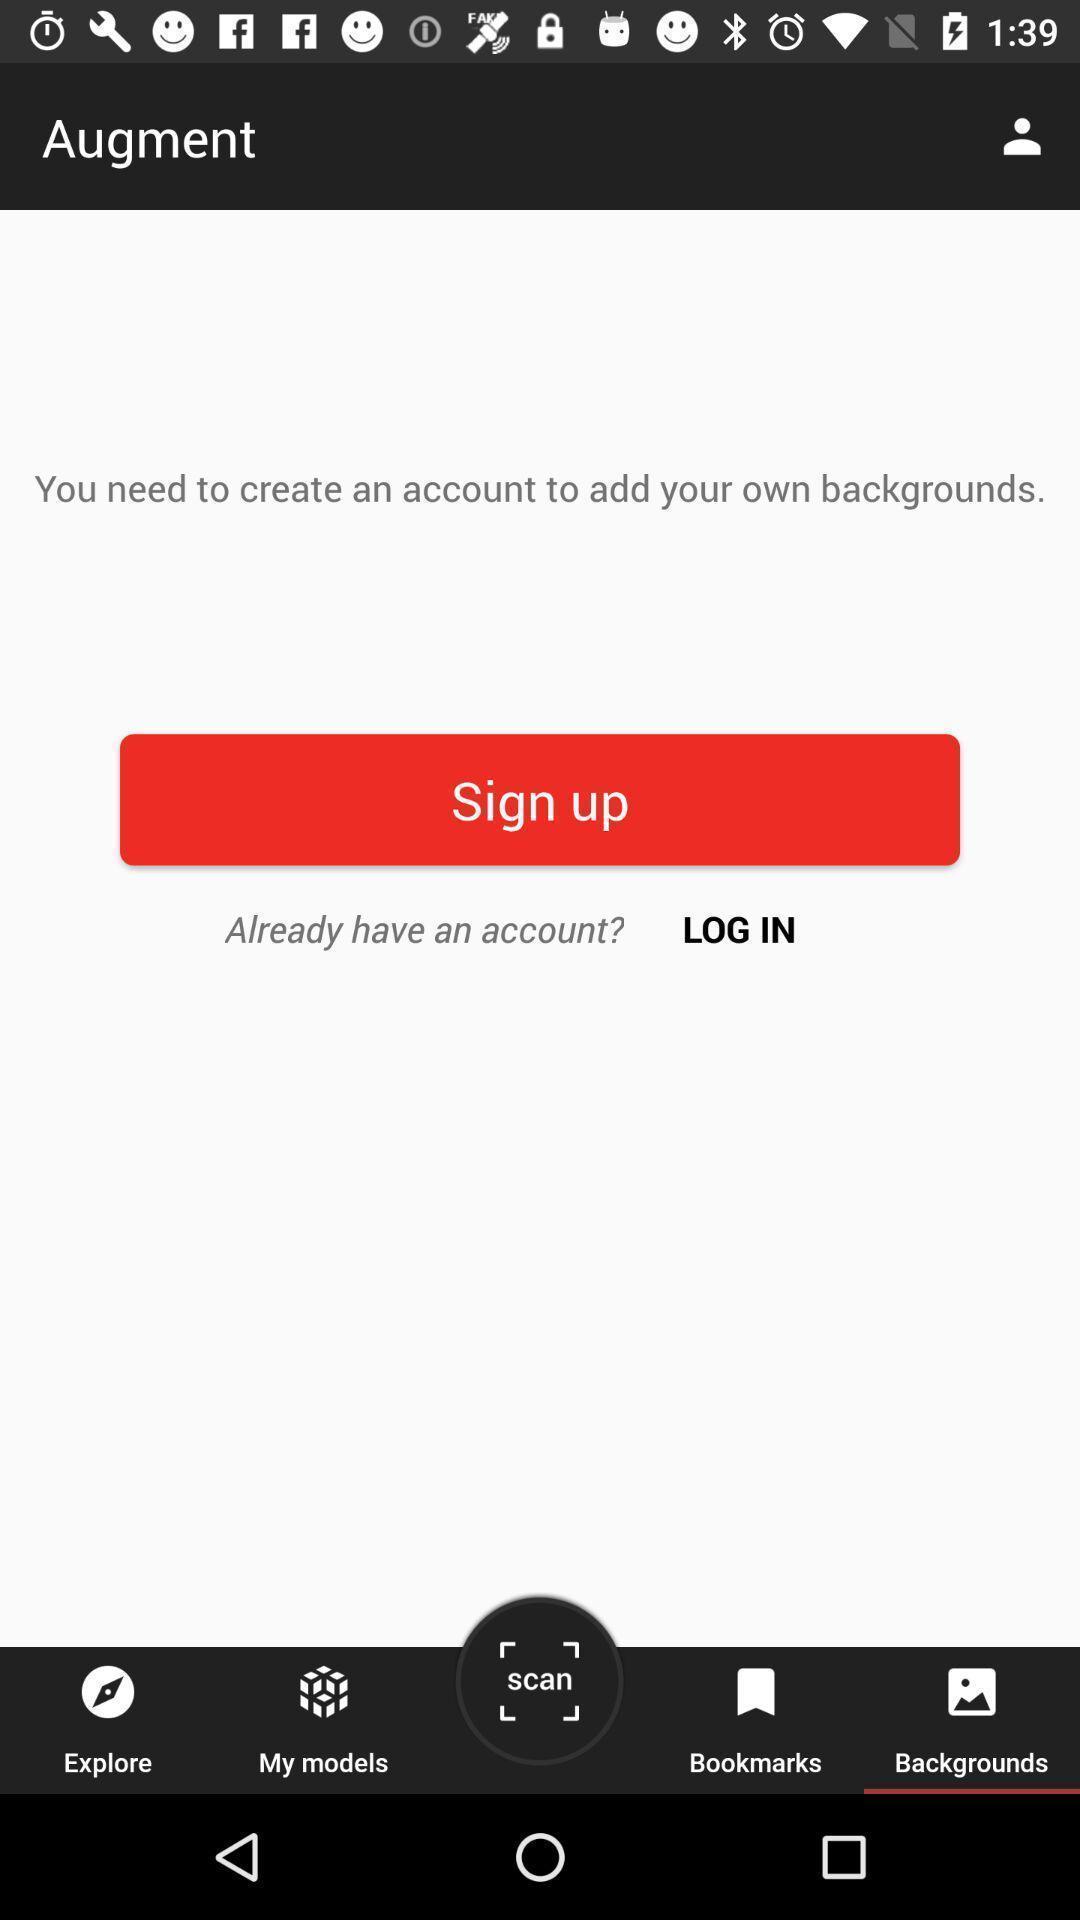Provide a detailed account of this screenshot. Sign up page of a social app. 